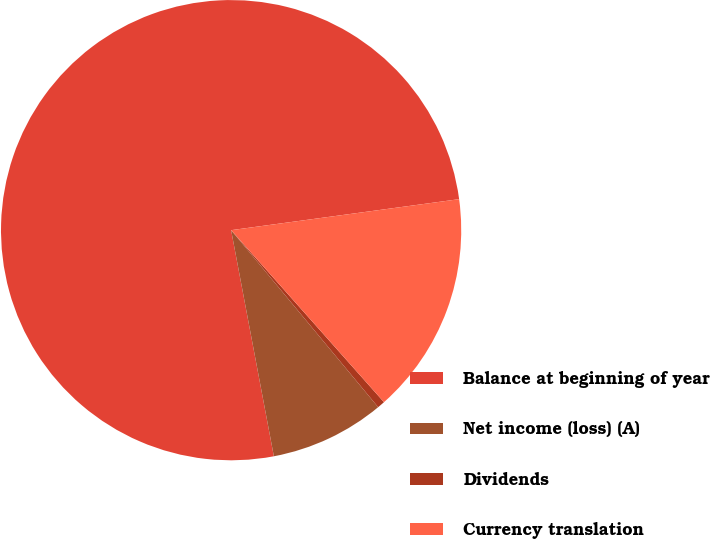Convert chart to OTSL. <chart><loc_0><loc_0><loc_500><loc_500><pie_chart><fcel>Balance at beginning of year<fcel>Net income (loss) (A)<fcel>Dividends<fcel>Currency translation<nl><fcel>75.83%<fcel>8.06%<fcel>0.53%<fcel>15.59%<nl></chart> 